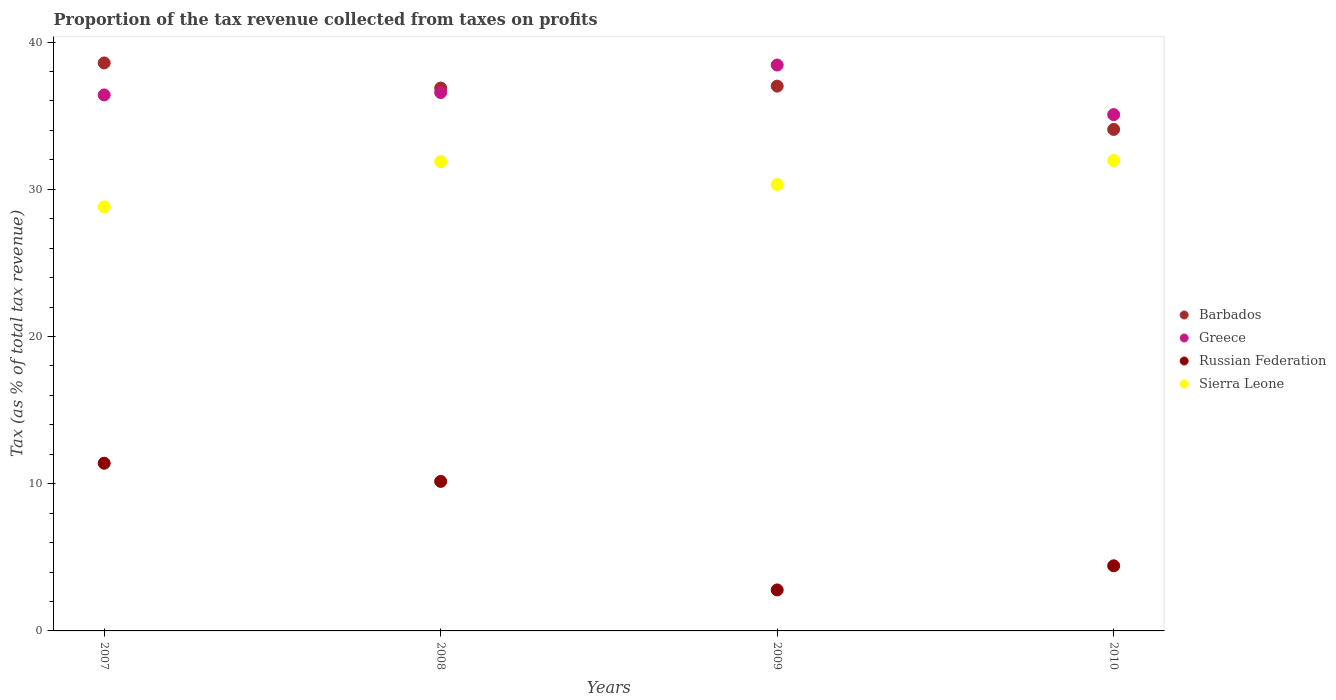What is the proportion of the tax revenue collected in Russian Federation in 2007?
Ensure brevity in your answer.  11.39. Across all years, what is the maximum proportion of the tax revenue collected in Greece?
Your response must be concise. 38.44. Across all years, what is the minimum proportion of the tax revenue collected in Greece?
Your answer should be compact. 35.07. In which year was the proportion of the tax revenue collected in Russian Federation maximum?
Provide a short and direct response. 2007. In which year was the proportion of the tax revenue collected in Barbados minimum?
Provide a succinct answer. 2010. What is the total proportion of the tax revenue collected in Sierra Leone in the graph?
Your response must be concise. 122.95. What is the difference between the proportion of the tax revenue collected in Greece in 2007 and that in 2008?
Provide a short and direct response. -0.16. What is the difference between the proportion of the tax revenue collected in Sierra Leone in 2010 and the proportion of the tax revenue collected in Barbados in 2008?
Give a very brief answer. -4.92. What is the average proportion of the tax revenue collected in Russian Federation per year?
Make the answer very short. 7.19. In the year 2008, what is the difference between the proportion of the tax revenue collected in Russian Federation and proportion of the tax revenue collected in Greece?
Give a very brief answer. -26.41. In how many years, is the proportion of the tax revenue collected in Russian Federation greater than 26 %?
Give a very brief answer. 0. What is the ratio of the proportion of the tax revenue collected in Russian Federation in 2009 to that in 2010?
Your answer should be very brief. 0.63. What is the difference between the highest and the second highest proportion of the tax revenue collected in Greece?
Provide a succinct answer. 1.87. What is the difference between the highest and the lowest proportion of the tax revenue collected in Sierra Leone?
Keep it short and to the point. 3.15. In how many years, is the proportion of the tax revenue collected in Greece greater than the average proportion of the tax revenue collected in Greece taken over all years?
Give a very brief answer. 1. Is the sum of the proportion of the tax revenue collected in Barbados in 2008 and 2010 greater than the maximum proportion of the tax revenue collected in Greece across all years?
Keep it short and to the point. Yes. Is it the case that in every year, the sum of the proportion of the tax revenue collected in Greece and proportion of the tax revenue collected in Russian Federation  is greater than the proportion of the tax revenue collected in Barbados?
Your answer should be compact. Yes. Does the proportion of the tax revenue collected in Sierra Leone monotonically increase over the years?
Offer a very short reply. No. What is the difference between two consecutive major ticks on the Y-axis?
Offer a very short reply. 10. Does the graph contain any zero values?
Keep it short and to the point. No. Does the graph contain grids?
Provide a short and direct response. No. How many legend labels are there?
Make the answer very short. 4. What is the title of the graph?
Ensure brevity in your answer.  Proportion of the tax revenue collected from taxes on profits. Does "Channel Islands" appear as one of the legend labels in the graph?
Ensure brevity in your answer.  No. What is the label or title of the X-axis?
Ensure brevity in your answer.  Years. What is the label or title of the Y-axis?
Keep it short and to the point. Tax (as % of total tax revenue). What is the Tax (as % of total tax revenue) of Barbados in 2007?
Offer a very short reply. 38.58. What is the Tax (as % of total tax revenue) in Greece in 2007?
Your answer should be compact. 36.41. What is the Tax (as % of total tax revenue) in Russian Federation in 2007?
Offer a terse response. 11.39. What is the Tax (as % of total tax revenue) in Sierra Leone in 2007?
Provide a short and direct response. 28.8. What is the Tax (as % of total tax revenue) in Barbados in 2008?
Ensure brevity in your answer.  36.88. What is the Tax (as % of total tax revenue) in Greece in 2008?
Make the answer very short. 36.57. What is the Tax (as % of total tax revenue) in Russian Federation in 2008?
Provide a short and direct response. 10.16. What is the Tax (as % of total tax revenue) of Sierra Leone in 2008?
Keep it short and to the point. 31.87. What is the Tax (as % of total tax revenue) in Barbados in 2009?
Ensure brevity in your answer.  37.01. What is the Tax (as % of total tax revenue) of Greece in 2009?
Keep it short and to the point. 38.44. What is the Tax (as % of total tax revenue) of Russian Federation in 2009?
Provide a short and direct response. 2.78. What is the Tax (as % of total tax revenue) of Sierra Leone in 2009?
Ensure brevity in your answer.  30.32. What is the Tax (as % of total tax revenue) in Barbados in 2010?
Your answer should be compact. 34.07. What is the Tax (as % of total tax revenue) of Greece in 2010?
Ensure brevity in your answer.  35.07. What is the Tax (as % of total tax revenue) of Russian Federation in 2010?
Provide a succinct answer. 4.42. What is the Tax (as % of total tax revenue) of Sierra Leone in 2010?
Your response must be concise. 31.95. Across all years, what is the maximum Tax (as % of total tax revenue) of Barbados?
Offer a terse response. 38.58. Across all years, what is the maximum Tax (as % of total tax revenue) in Greece?
Offer a terse response. 38.44. Across all years, what is the maximum Tax (as % of total tax revenue) of Russian Federation?
Make the answer very short. 11.39. Across all years, what is the maximum Tax (as % of total tax revenue) in Sierra Leone?
Keep it short and to the point. 31.95. Across all years, what is the minimum Tax (as % of total tax revenue) in Barbados?
Your answer should be very brief. 34.07. Across all years, what is the minimum Tax (as % of total tax revenue) of Greece?
Offer a very short reply. 35.07. Across all years, what is the minimum Tax (as % of total tax revenue) in Russian Federation?
Ensure brevity in your answer.  2.78. Across all years, what is the minimum Tax (as % of total tax revenue) of Sierra Leone?
Provide a short and direct response. 28.8. What is the total Tax (as % of total tax revenue) of Barbados in the graph?
Your answer should be compact. 146.53. What is the total Tax (as % of total tax revenue) of Greece in the graph?
Offer a terse response. 146.49. What is the total Tax (as % of total tax revenue) of Russian Federation in the graph?
Provide a succinct answer. 28.76. What is the total Tax (as % of total tax revenue) in Sierra Leone in the graph?
Give a very brief answer. 122.95. What is the difference between the Tax (as % of total tax revenue) in Barbados in 2007 and that in 2008?
Offer a very short reply. 1.71. What is the difference between the Tax (as % of total tax revenue) of Greece in 2007 and that in 2008?
Your answer should be compact. -0.16. What is the difference between the Tax (as % of total tax revenue) in Russian Federation in 2007 and that in 2008?
Your response must be concise. 1.24. What is the difference between the Tax (as % of total tax revenue) in Sierra Leone in 2007 and that in 2008?
Provide a short and direct response. -3.07. What is the difference between the Tax (as % of total tax revenue) in Barbados in 2007 and that in 2009?
Ensure brevity in your answer.  1.58. What is the difference between the Tax (as % of total tax revenue) in Greece in 2007 and that in 2009?
Give a very brief answer. -2.03. What is the difference between the Tax (as % of total tax revenue) of Russian Federation in 2007 and that in 2009?
Your answer should be compact. 8.61. What is the difference between the Tax (as % of total tax revenue) in Sierra Leone in 2007 and that in 2009?
Ensure brevity in your answer.  -1.52. What is the difference between the Tax (as % of total tax revenue) in Barbados in 2007 and that in 2010?
Ensure brevity in your answer.  4.52. What is the difference between the Tax (as % of total tax revenue) in Greece in 2007 and that in 2010?
Your answer should be compact. 1.34. What is the difference between the Tax (as % of total tax revenue) of Russian Federation in 2007 and that in 2010?
Offer a very short reply. 6.97. What is the difference between the Tax (as % of total tax revenue) in Sierra Leone in 2007 and that in 2010?
Offer a terse response. -3.15. What is the difference between the Tax (as % of total tax revenue) of Barbados in 2008 and that in 2009?
Give a very brief answer. -0.13. What is the difference between the Tax (as % of total tax revenue) of Greece in 2008 and that in 2009?
Your answer should be very brief. -1.87. What is the difference between the Tax (as % of total tax revenue) in Russian Federation in 2008 and that in 2009?
Your answer should be compact. 7.37. What is the difference between the Tax (as % of total tax revenue) in Sierra Leone in 2008 and that in 2009?
Provide a short and direct response. 1.55. What is the difference between the Tax (as % of total tax revenue) of Barbados in 2008 and that in 2010?
Keep it short and to the point. 2.81. What is the difference between the Tax (as % of total tax revenue) of Greece in 2008 and that in 2010?
Offer a very short reply. 1.5. What is the difference between the Tax (as % of total tax revenue) of Russian Federation in 2008 and that in 2010?
Your answer should be compact. 5.73. What is the difference between the Tax (as % of total tax revenue) in Sierra Leone in 2008 and that in 2010?
Offer a terse response. -0.08. What is the difference between the Tax (as % of total tax revenue) of Barbados in 2009 and that in 2010?
Give a very brief answer. 2.94. What is the difference between the Tax (as % of total tax revenue) in Greece in 2009 and that in 2010?
Provide a succinct answer. 3.37. What is the difference between the Tax (as % of total tax revenue) of Russian Federation in 2009 and that in 2010?
Provide a short and direct response. -1.64. What is the difference between the Tax (as % of total tax revenue) in Sierra Leone in 2009 and that in 2010?
Keep it short and to the point. -1.63. What is the difference between the Tax (as % of total tax revenue) in Barbados in 2007 and the Tax (as % of total tax revenue) in Greece in 2008?
Offer a terse response. 2.01. What is the difference between the Tax (as % of total tax revenue) of Barbados in 2007 and the Tax (as % of total tax revenue) of Russian Federation in 2008?
Provide a short and direct response. 28.43. What is the difference between the Tax (as % of total tax revenue) in Barbados in 2007 and the Tax (as % of total tax revenue) in Sierra Leone in 2008?
Ensure brevity in your answer.  6.71. What is the difference between the Tax (as % of total tax revenue) in Greece in 2007 and the Tax (as % of total tax revenue) in Russian Federation in 2008?
Provide a succinct answer. 26.25. What is the difference between the Tax (as % of total tax revenue) of Greece in 2007 and the Tax (as % of total tax revenue) of Sierra Leone in 2008?
Ensure brevity in your answer.  4.53. What is the difference between the Tax (as % of total tax revenue) in Russian Federation in 2007 and the Tax (as % of total tax revenue) in Sierra Leone in 2008?
Your answer should be very brief. -20.48. What is the difference between the Tax (as % of total tax revenue) of Barbados in 2007 and the Tax (as % of total tax revenue) of Greece in 2009?
Your response must be concise. 0.14. What is the difference between the Tax (as % of total tax revenue) in Barbados in 2007 and the Tax (as % of total tax revenue) in Russian Federation in 2009?
Ensure brevity in your answer.  35.8. What is the difference between the Tax (as % of total tax revenue) of Barbados in 2007 and the Tax (as % of total tax revenue) of Sierra Leone in 2009?
Your response must be concise. 8.26. What is the difference between the Tax (as % of total tax revenue) in Greece in 2007 and the Tax (as % of total tax revenue) in Russian Federation in 2009?
Make the answer very short. 33.62. What is the difference between the Tax (as % of total tax revenue) of Greece in 2007 and the Tax (as % of total tax revenue) of Sierra Leone in 2009?
Make the answer very short. 6.09. What is the difference between the Tax (as % of total tax revenue) in Russian Federation in 2007 and the Tax (as % of total tax revenue) in Sierra Leone in 2009?
Your answer should be very brief. -18.93. What is the difference between the Tax (as % of total tax revenue) in Barbados in 2007 and the Tax (as % of total tax revenue) in Greece in 2010?
Give a very brief answer. 3.51. What is the difference between the Tax (as % of total tax revenue) of Barbados in 2007 and the Tax (as % of total tax revenue) of Russian Federation in 2010?
Make the answer very short. 34.16. What is the difference between the Tax (as % of total tax revenue) in Barbados in 2007 and the Tax (as % of total tax revenue) in Sierra Leone in 2010?
Keep it short and to the point. 6.63. What is the difference between the Tax (as % of total tax revenue) in Greece in 2007 and the Tax (as % of total tax revenue) in Russian Federation in 2010?
Make the answer very short. 31.98. What is the difference between the Tax (as % of total tax revenue) in Greece in 2007 and the Tax (as % of total tax revenue) in Sierra Leone in 2010?
Give a very brief answer. 4.45. What is the difference between the Tax (as % of total tax revenue) of Russian Federation in 2007 and the Tax (as % of total tax revenue) of Sierra Leone in 2010?
Give a very brief answer. -20.56. What is the difference between the Tax (as % of total tax revenue) of Barbados in 2008 and the Tax (as % of total tax revenue) of Greece in 2009?
Your answer should be very brief. -1.56. What is the difference between the Tax (as % of total tax revenue) in Barbados in 2008 and the Tax (as % of total tax revenue) in Russian Federation in 2009?
Offer a very short reply. 34.09. What is the difference between the Tax (as % of total tax revenue) in Barbados in 2008 and the Tax (as % of total tax revenue) in Sierra Leone in 2009?
Your response must be concise. 6.55. What is the difference between the Tax (as % of total tax revenue) of Greece in 2008 and the Tax (as % of total tax revenue) of Russian Federation in 2009?
Ensure brevity in your answer.  33.79. What is the difference between the Tax (as % of total tax revenue) in Greece in 2008 and the Tax (as % of total tax revenue) in Sierra Leone in 2009?
Your answer should be compact. 6.25. What is the difference between the Tax (as % of total tax revenue) in Russian Federation in 2008 and the Tax (as % of total tax revenue) in Sierra Leone in 2009?
Ensure brevity in your answer.  -20.16. What is the difference between the Tax (as % of total tax revenue) in Barbados in 2008 and the Tax (as % of total tax revenue) in Greece in 2010?
Your answer should be compact. 1.81. What is the difference between the Tax (as % of total tax revenue) in Barbados in 2008 and the Tax (as % of total tax revenue) in Russian Federation in 2010?
Your answer should be compact. 32.45. What is the difference between the Tax (as % of total tax revenue) of Barbados in 2008 and the Tax (as % of total tax revenue) of Sierra Leone in 2010?
Provide a short and direct response. 4.92. What is the difference between the Tax (as % of total tax revenue) of Greece in 2008 and the Tax (as % of total tax revenue) of Russian Federation in 2010?
Offer a terse response. 32.15. What is the difference between the Tax (as % of total tax revenue) of Greece in 2008 and the Tax (as % of total tax revenue) of Sierra Leone in 2010?
Your answer should be compact. 4.62. What is the difference between the Tax (as % of total tax revenue) in Russian Federation in 2008 and the Tax (as % of total tax revenue) in Sierra Leone in 2010?
Keep it short and to the point. -21.8. What is the difference between the Tax (as % of total tax revenue) of Barbados in 2009 and the Tax (as % of total tax revenue) of Greece in 2010?
Keep it short and to the point. 1.94. What is the difference between the Tax (as % of total tax revenue) in Barbados in 2009 and the Tax (as % of total tax revenue) in Russian Federation in 2010?
Your answer should be compact. 32.58. What is the difference between the Tax (as % of total tax revenue) of Barbados in 2009 and the Tax (as % of total tax revenue) of Sierra Leone in 2010?
Make the answer very short. 5.05. What is the difference between the Tax (as % of total tax revenue) of Greece in 2009 and the Tax (as % of total tax revenue) of Russian Federation in 2010?
Offer a very short reply. 34.02. What is the difference between the Tax (as % of total tax revenue) of Greece in 2009 and the Tax (as % of total tax revenue) of Sierra Leone in 2010?
Make the answer very short. 6.49. What is the difference between the Tax (as % of total tax revenue) of Russian Federation in 2009 and the Tax (as % of total tax revenue) of Sierra Leone in 2010?
Give a very brief answer. -29.17. What is the average Tax (as % of total tax revenue) of Barbados per year?
Your response must be concise. 36.63. What is the average Tax (as % of total tax revenue) of Greece per year?
Offer a very short reply. 36.62. What is the average Tax (as % of total tax revenue) in Russian Federation per year?
Offer a very short reply. 7.19. What is the average Tax (as % of total tax revenue) of Sierra Leone per year?
Your answer should be compact. 30.74. In the year 2007, what is the difference between the Tax (as % of total tax revenue) in Barbados and Tax (as % of total tax revenue) in Greece?
Give a very brief answer. 2.17. In the year 2007, what is the difference between the Tax (as % of total tax revenue) in Barbados and Tax (as % of total tax revenue) in Russian Federation?
Provide a short and direct response. 27.19. In the year 2007, what is the difference between the Tax (as % of total tax revenue) of Barbados and Tax (as % of total tax revenue) of Sierra Leone?
Provide a succinct answer. 9.78. In the year 2007, what is the difference between the Tax (as % of total tax revenue) of Greece and Tax (as % of total tax revenue) of Russian Federation?
Your response must be concise. 25.02. In the year 2007, what is the difference between the Tax (as % of total tax revenue) in Greece and Tax (as % of total tax revenue) in Sierra Leone?
Provide a short and direct response. 7.61. In the year 2007, what is the difference between the Tax (as % of total tax revenue) of Russian Federation and Tax (as % of total tax revenue) of Sierra Leone?
Your answer should be compact. -17.41. In the year 2008, what is the difference between the Tax (as % of total tax revenue) in Barbados and Tax (as % of total tax revenue) in Greece?
Offer a terse response. 0.3. In the year 2008, what is the difference between the Tax (as % of total tax revenue) of Barbados and Tax (as % of total tax revenue) of Russian Federation?
Keep it short and to the point. 26.72. In the year 2008, what is the difference between the Tax (as % of total tax revenue) in Barbados and Tax (as % of total tax revenue) in Sierra Leone?
Offer a terse response. 5. In the year 2008, what is the difference between the Tax (as % of total tax revenue) in Greece and Tax (as % of total tax revenue) in Russian Federation?
Your answer should be compact. 26.41. In the year 2008, what is the difference between the Tax (as % of total tax revenue) of Greece and Tax (as % of total tax revenue) of Sierra Leone?
Offer a very short reply. 4.7. In the year 2008, what is the difference between the Tax (as % of total tax revenue) of Russian Federation and Tax (as % of total tax revenue) of Sierra Leone?
Offer a very short reply. -21.72. In the year 2009, what is the difference between the Tax (as % of total tax revenue) in Barbados and Tax (as % of total tax revenue) in Greece?
Your answer should be very brief. -1.43. In the year 2009, what is the difference between the Tax (as % of total tax revenue) in Barbados and Tax (as % of total tax revenue) in Russian Federation?
Offer a very short reply. 34.22. In the year 2009, what is the difference between the Tax (as % of total tax revenue) in Barbados and Tax (as % of total tax revenue) in Sierra Leone?
Your answer should be compact. 6.69. In the year 2009, what is the difference between the Tax (as % of total tax revenue) of Greece and Tax (as % of total tax revenue) of Russian Federation?
Provide a succinct answer. 35.65. In the year 2009, what is the difference between the Tax (as % of total tax revenue) of Greece and Tax (as % of total tax revenue) of Sierra Leone?
Offer a terse response. 8.12. In the year 2009, what is the difference between the Tax (as % of total tax revenue) of Russian Federation and Tax (as % of total tax revenue) of Sierra Leone?
Offer a very short reply. -27.54. In the year 2010, what is the difference between the Tax (as % of total tax revenue) of Barbados and Tax (as % of total tax revenue) of Greece?
Your response must be concise. -1. In the year 2010, what is the difference between the Tax (as % of total tax revenue) of Barbados and Tax (as % of total tax revenue) of Russian Federation?
Make the answer very short. 29.64. In the year 2010, what is the difference between the Tax (as % of total tax revenue) in Barbados and Tax (as % of total tax revenue) in Sierra Leone?
Ensure brevity in your answer.  2.11. In the year 2010, what is the difference between the Tax (as % of total tax revenue) of Greece and Tax (as % of total tax revenue) of Russian Federation?
Your answer should be very brief. 30.65. In the year 2010, what is the difference between the Tax (as % of total tax revenue) in Greece and Tax (as % of total tax revenue) in Sierra Leone?
Offer a very short reply. 3.12. In the year 2010, what is the difference between the Tax (as % of total tax revenue) of Russian Federation and Tax (as % of total tax revenue) of Sierra Leone?
Your response must be concise. -27.53. What is the ratio of the Tax (as % of total tax revenue) of Barbados in 2007 to that in 2008?
Your answer should be very brief. 1.05. What is the ratio of the Tax (as % of total tax revenue) in Greece in 2007 to that in 2008?
Keep it short and to the point. 1. What is the ratio of the Tax (as % of total tax revenue) of Russian Federation in 2007 to that in 2008?
Your answer should be very brief. 1.12. What is the ratio of the Tax (as % of total tax revenue) of Sierra Leone in 2007 to that in 2008?
Ensure brevity in your answer.  0.9. What is the ratio of the Tax (as % of total tax revenue) of Barbados in 2007 to that in 2009?
Your response must be concise. 1.04. What is the ratio of the Tax (as % of total tax revenue) in Greece in 2007 to that in 2009?
Provide a succinct answer. 0.95. What is the ratio of the Tax (as % of total tax revenue) in Russian Federation in 2007 to that in 2009?
Provide a short and direct response. 4.09. What is the ratio of the Tax (as % of total tax revenue) in Sierra Leone in 2007 to that in 2009?
Your answer should be compact. 0.95. What is the ratio of the Tax (as % of total tax revenue) of Barbados in 2007 to that in 2010?
Keep it short and to the point. 1.13. What is the ratio of the Tax (as % of total tax revenue) in Greece in 2007 to that in 2010?
Your response must be concise. 1.04. What is the ratio of the Tax (as % of total tax revenue) of Russian Federation in 2007 to that in 2010?
Your answer should be compact. 2.58. What is the ratio of the Tax (as % of total tax revenue) of Sierra Leone in 2007 to that in 2010?
Offer a very short reply. 0.9. What is the ratio of the Tax (as % of total tax revenue) in Greece in 2008 to that in 2009?
Your answer should be compact. 0.95. What is the ratio of the Tax (as % of total tax revenue) in Russian Federation in 2008 to that in 2009?
Offer a terse response. 3.65. What is the ratio of the Tax (as % of total tax revenue) in Sierra Leone in 2008 to that in 2009?
Provide a short and direct response. 1.05. What is the ratio of the Tax (as % of total tax revenue) in Barbados in 2008 to that in 2010?
Make the answer very short. 1.08. What is the ratio of the Tax (as % of total tax revenue) of Greece in 2008 to that in 2010?
Ensure brevity in your answer.  1.04. What is the ratio of the Tax (as % of total tax revenue) in Russian Federation in 2008 to that in 2010?
Keep it short and to the point. 2.3. What is the ratio of the Tax (as % of total tax revenue) of Sierra Leone in 2008 to that in 2010?
Your response must be concise. 1. What is the ratio of the Tax (as % of total tax revenue) in Barbados in 2009 to that in 2010?
Make the answer very short. 1.09. What is the ratio of the Tax (as % of total tax revenue) of Greece in 2009 to that in 2010?
Provide a short and direct response. 1.1. What is the ratio of the Tax (as % of total tax revenue) of Russian Federation in 2009 to that in 2010?
Your response must be concise. 0.63. What is the ratio of the Tax (as % of total tax revenue) of Sierra Leone in 2009 to that in 2010?
Your response must be concise. 0.95. What is the difference between the highest and the second highest Tax (as % of total tax revenue) in Barbados?
Provide a short and direct response. 1.58. What is the difference between the highest and the second highest Tax (as % of total tax revenue) in Greece?
Give a very brief answer. 1.87. What is the difference between the highest and the second highest Tax (as % of total tax revenue) in Russian Federation?
Give a very brief answer. 1.24. What is the difference between the highest and the second highest Tax (as % of total tax revenue) in Sierra Leone?
Keep it short and to the point. 0.08. What is the difference between the highest and the lowest Tax (as % of total tax revenue) in Barbados?
Your answer should be very brief. 4.52. What is the difference between the highest and the lowest Tax (as % of total tax revenue) of Greece?
Your answer should be very brief. 3.37. What is the difference between the highest and the lowest Tax (as % of total tax revenue) of Russian Federation?
Provide a succinct answer. 8.61. What is the difference between the highest and the lowest Tax (as % of total tax revenue) of Sierra Leone?
Ensure brevity in your answer.  3.15. 